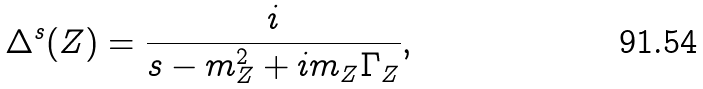Convert formula to latex. <formula><loc_0><loc_0><loc_500><loc_500>\Delta ^ { s } ( Z ) = \frac { i } { s - m _ { Z } ^ { 2 } + i m _ { Z } \Gamma _ { Z } } ,</formula> 